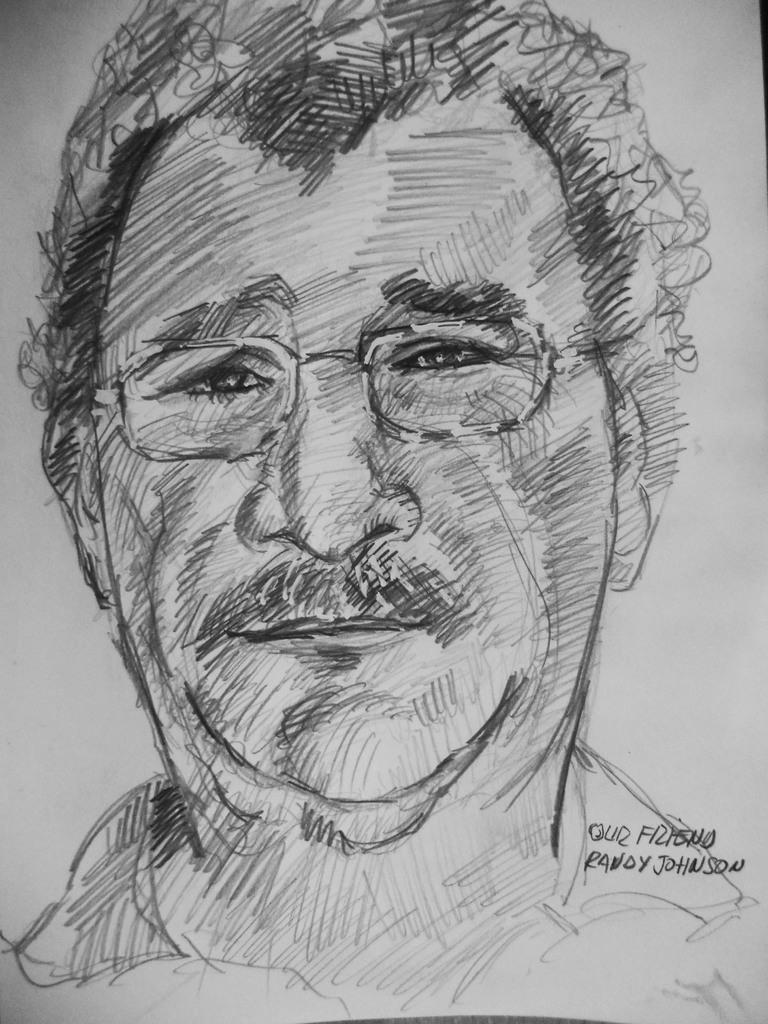What is depicted on the paper in the image? There is a drawing of a person in the image. What else can be found on the paper besides the drawing? There are words on the paper in the image. What type of riddle is the person in the image trying to solve? There is no riddle present in the image; it only features a drawing of a person and words on the paper. 